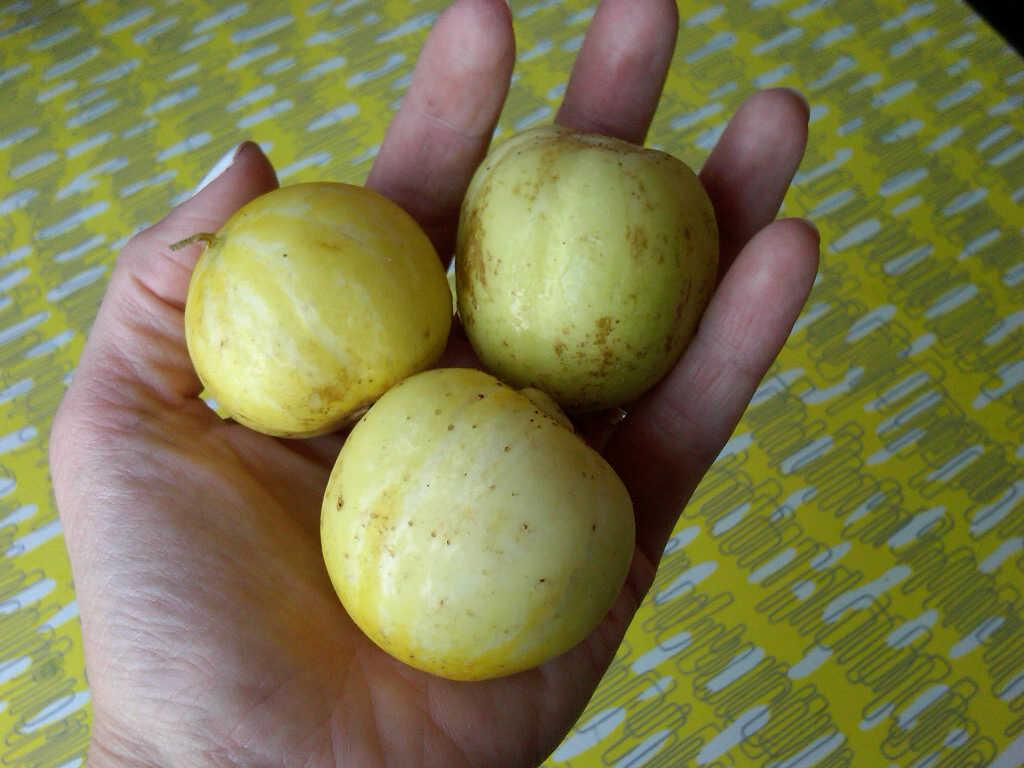How many fruits can be seen in the image? There are three fruits in the image. Where are the fruits located? The fruits are in a human hand. What type of cub can be seen playing with the waves in the image? There is no cub or waves present in the image. 